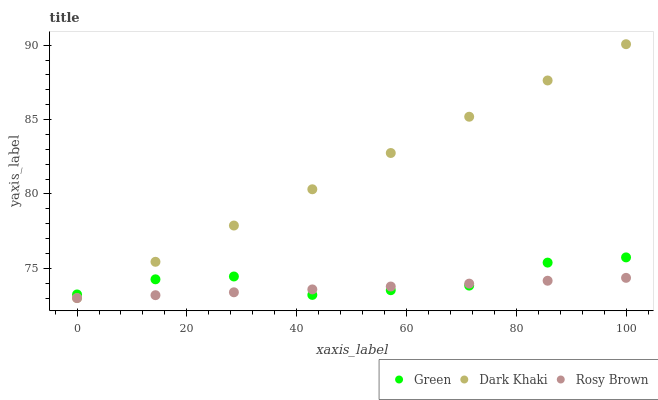Does Rosy Brown have the minimum area under the curve?
Answer yes or no. Yes. Does Dark Khaki have the maximum area under the curve?
Answer yes or no. Yes. Does Green have the minimum area under the curve?
Answer yes or no. No. Does Green have the maximum area under the curve?
Answer yes or no. No. Is Rosy Brown the smoothest?
Answer yes or no. Yes. Is Green the roughest?
Answer yes or no. Yes. Is Green the smoothest?
Answer yes or no. No. Is Rosy Brown the roughest?
Answer yes or no. No. Does Dark Khaki have the lowest value?
Answer yes or no. Yes. Does Green have the lowest value?
Answer yes or no. No. Does Dark Khaki have the highest value?
Answer yes or no. Yes. Does Green have the highest value?
Answer yes or no. No. Does Rosy Brown intersect Dark Khaki?
Answer yes or no. Yes. Is Rosy Brown less than Dark Khaki?
Answer yes or no. No. Is Rosy Brown greater than Dark Khaki?
Answer yes or no. No. 